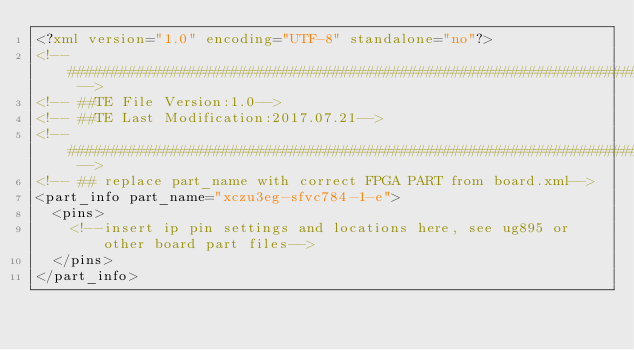<code> <loc_0><loc_0><loc_500><loc_500><_XML_><?xml version="1.0" encoding="UTF-8" standalone="no"?> 
<!-- ##################################################################### -->
<!-- ##TE File Version:1.0-->
<!-- ##TE Last Modification:2017.07.21-->
<!-- ##################################################################### -->
<!-- ## replace part_name with correct FPGA PART from board.xml-->
<part_info part_name="xczu3eg-sfvc784-1-e">
  <pins>
    <!--insert ip pin settings and locations here, see ug895 or other board part files-->
  </pins>
</part_info>
</code> 